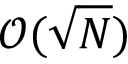Convert formula to latex. <formula><loc_0><loc_0><loc_500><loc_500>\mathcal { O } ( \sqrt { N } )</formula> 